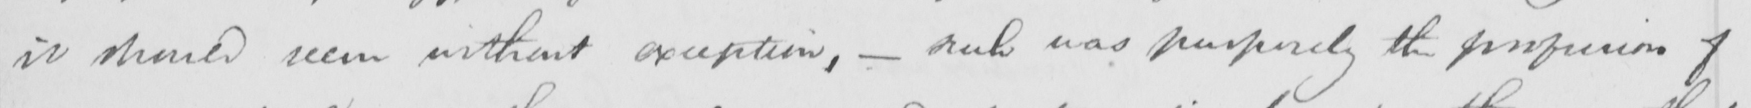Can you read and transcribe this handwriting? it should seem without exception ,  _  such was purposely the profusion of 